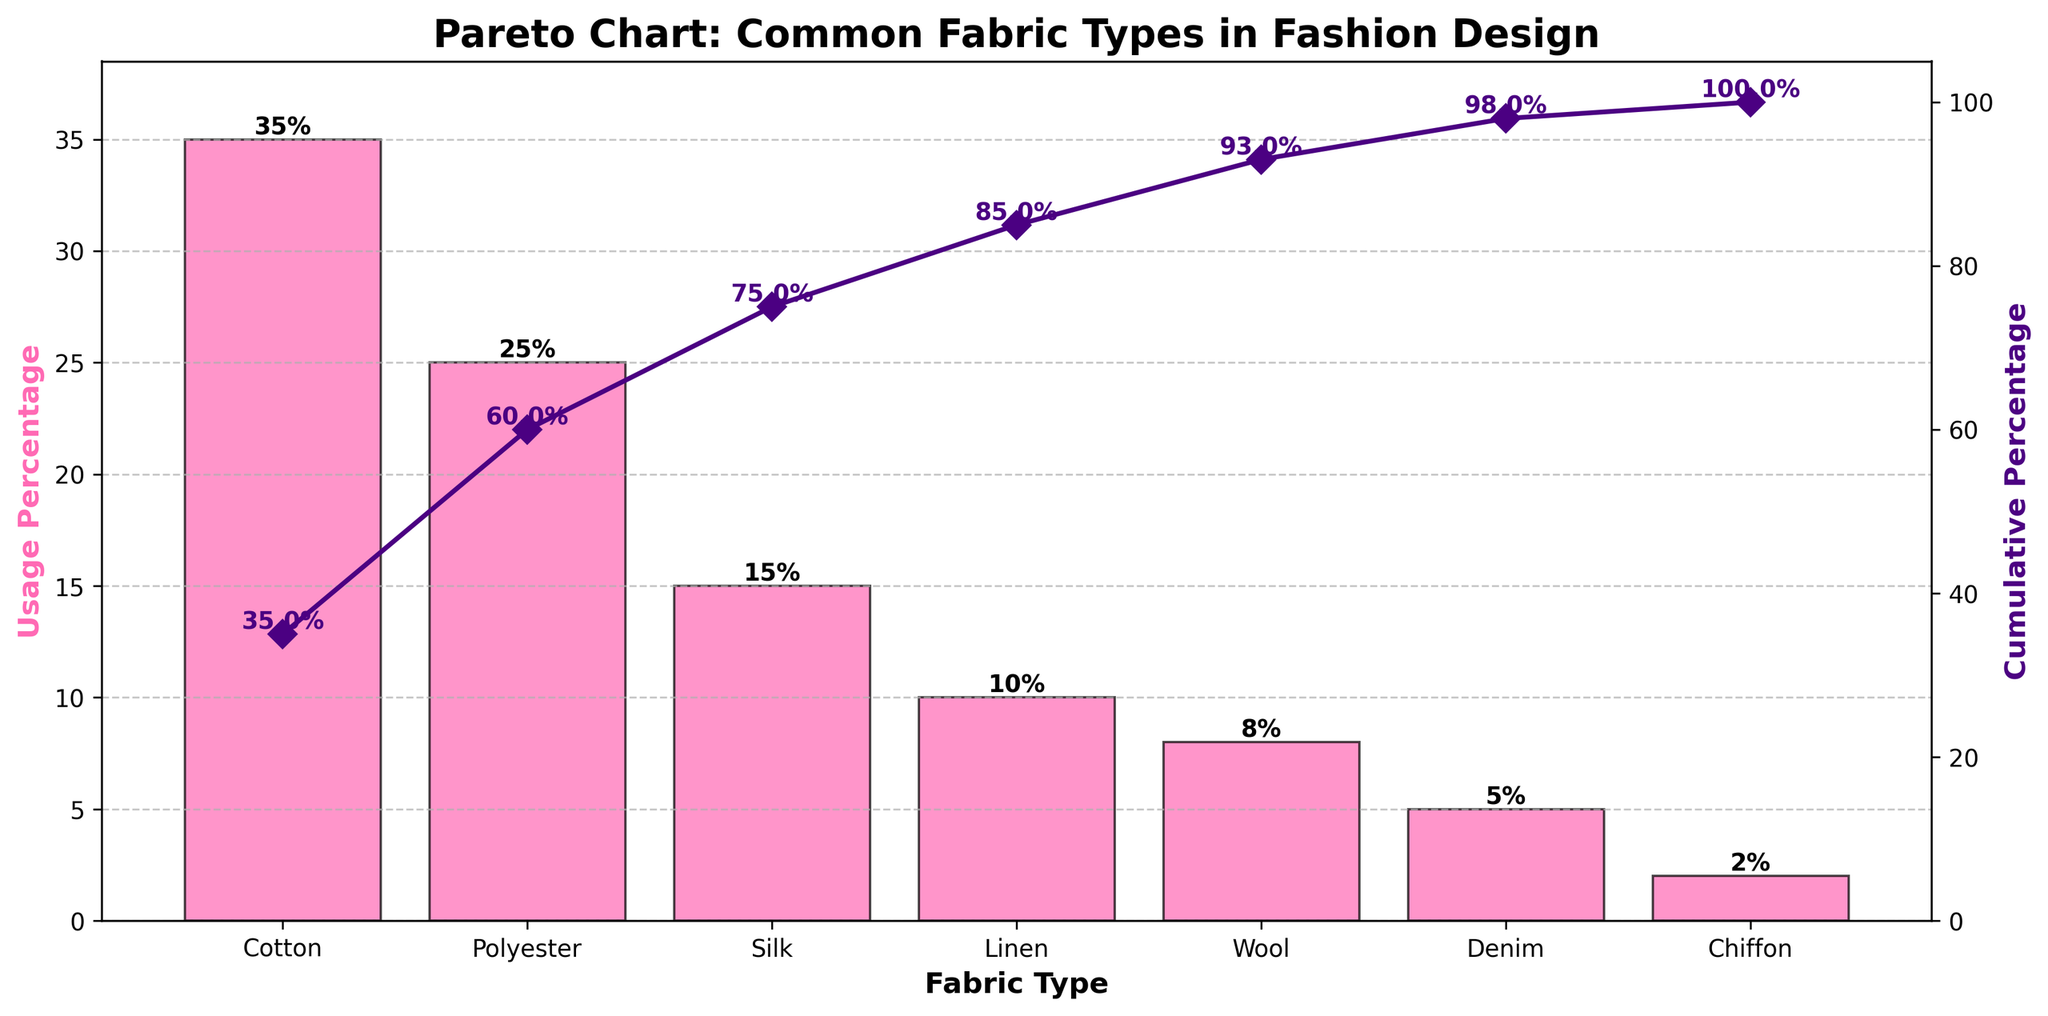What is the title of the chart? The title of the chart is located at the top and reads "Pareto Chart: Common Fabric Types in Fashion Design".
Answer: Pareto Chart: Common Fabric Types in Fashion Design What is the most popular fabric type according to the chart? The most popular fabric type is represented by the tallest bar in the chart, which is Cotton with a usage percentage of 35%.
Answer: Cotton Which fabric type has the lowest usage percentage? The shortest bar in the chart represents the fabric type with the lowest usage percentage, which is Chiffon at 2%.
Answer: Chiffon What is the cumulative usage percentage for the top three fabric types? Cumulative percentage is tracked by the line plot. Adding the percentages for Cotton, Polyester, and Silk gives 35% + 25% + 15% = 75%.
Answer: 75% By how much does the usage percentage of Polyester exceed that of Silk? Polyester's usage percentage is 25%, and Silk's is 15%. The difference is 25% - 15% = 10%.
Answer: 10% How many fabric types are represented in the chart? Count the number of bars in the chart, representing different fabric types. There are seven fabric types shown.
Answer: 7 What is the cumulative percentage just after Linen? The cumulative percentage after Linen can be found at the end of the fourth bar. Adding the percentages: 35% + 25% + 15% + 10% = 85%.
Answer: 85% Which fabric type is second most popular, and what is its usage percentage? The second tallest bar represents the second most popular fabric type, which is Polyester with a usage percentage of 25%.
Answer: Polyester, 25% What is the cumulative percentage line color, and what is the marker shape on it? The cumulative percentage line is colored in purple with diamond-shaped markers (D).
Answer: Purple, Diamond What total percentage of fabric usage do Cotton and Polyester represent? Adding the usage percentages for Cotton and Polyester gives 35% + 25% = 60%.
Answer: 60% 